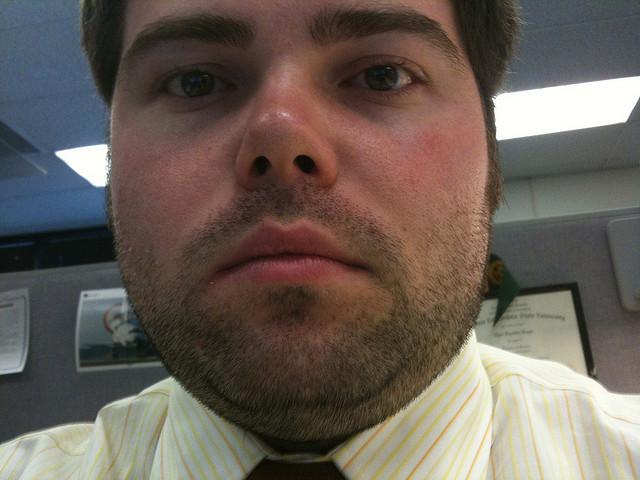Is he smiling?
Give a very brief answer. No. What color is the man's shirt?
Give a very brief answer. Yellow. Is this person at work?
Keep it brief. Yes. What is covering the man 's chin?
Keep it brief. Hair. 